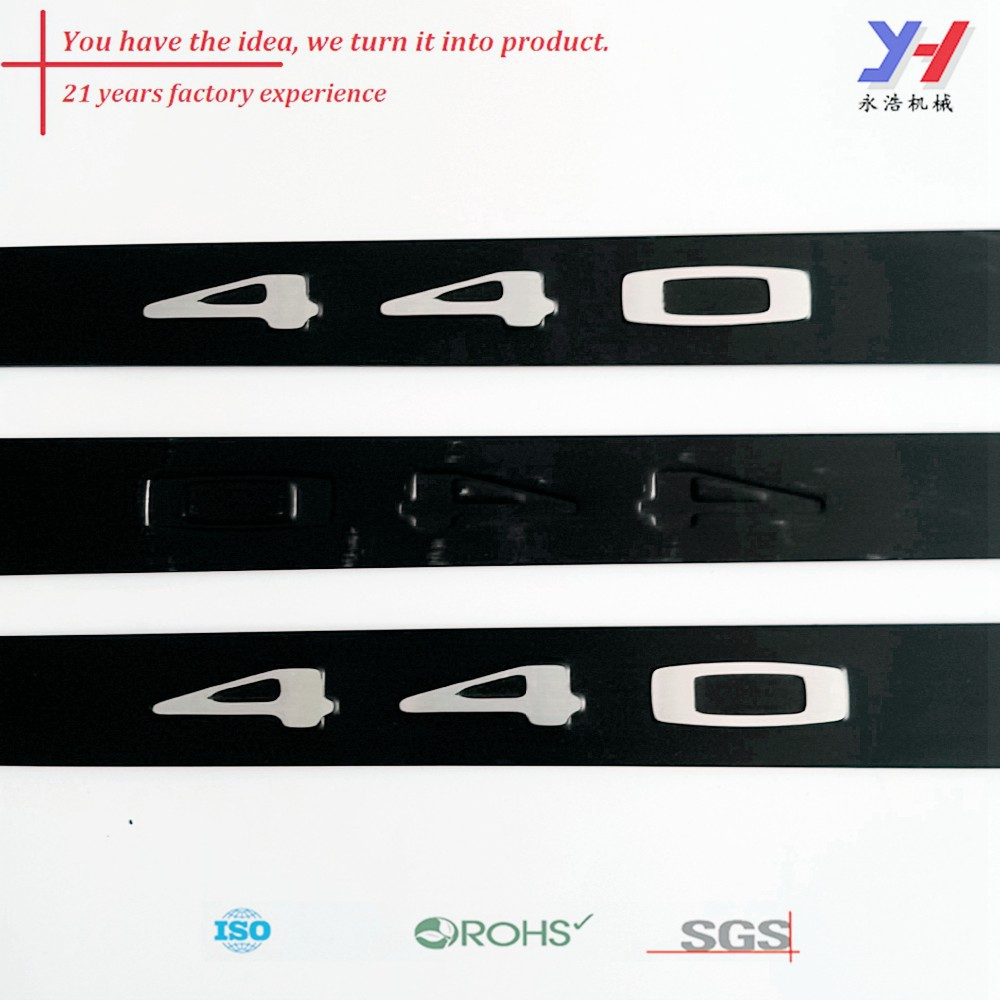What might the significance of the numbers "40" be in relation to the company's branding or products? The image does not provide explicit information about the significance of the numbers "40" in relation to the company's branding or products. However, given the context of the slogan and the mention of '21 years factory experience,' it is possible that '40' represents a milestone, anniversary, model number, or a specific product line that the company is highlighting. The stylized presentation of the numbers suggests that they are an essential part of the company's identity or marketing strategy, signifying something of importance or value to the brand. 